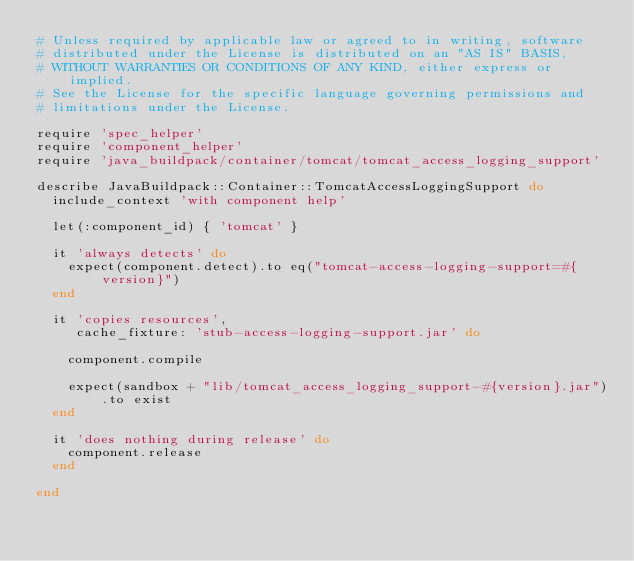<code> <loc_0><loc_0><loc_500><loc_500><_Ruby_># Unless required by applicable law or agreed to in writing, software
# distributed under the License is distributed on an "AS IS" BASIS,
# WITHOUT WARRANTIES OR CONDITIONS OF ANY KIND, either express or implied.
# See the License for the specific language governing permissions and
# limitations under the License.

require 'spec_helper'
require 'component_helper'
require 'java_buildpack/container/tomcat/tomcat_access_logging_support'

describe JavaBuildpack::Container::TomcatAccessLoggingSupport do
  include_context 'with component help'

  let(:component_id) { 'tomcat' }

  it 'always detects' do
    expect(component.detect).to eq("tomcat-access-logging-support=#{version}")
  end

  it 'copies resources',
     cache_fixture: 'stub-access-logging-support.jar' do

    component.compile

    expect(sandbox + "lib/tomcat_access_logging_support-#{version}.jar").to exist
  end

  it 'does nothing during release' do
    component.release
  end

end
</code> 